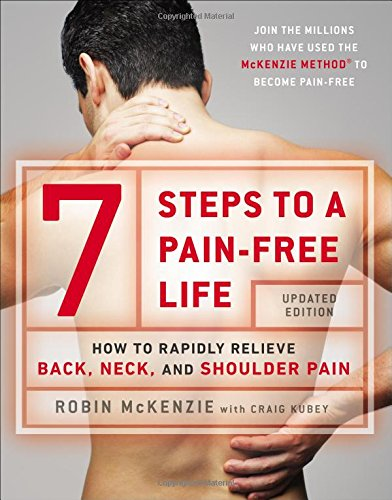Is this a motivational book? No, its primary aim is not to motivate but rather to educate and provide practical steps for physical health improvement, focusing on the McKenzie Method of mechanical diagnosis and therapy. 